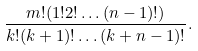Convert formula to latex. <formula><loc_0><loc_0><loc_500><loc_500>\frac { m ! ( 1 ! 2 ! \dots ( n - 1 ) ! ) } { k ! ( k + 1 ) ! \dots ( k + n - 1 ) ! } .</formula> 